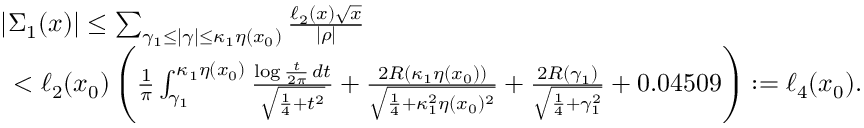<formula> <loc_0><loc_0><loc_500><loc_500>\begin{array} { r l } & { | \Sigma _ { 1 } ( x ) | \leq \sum _ { \gamma _ { 1 } \leq | \gamma | \leq \kappa _ { 1 } \eta ( x _ { 0 } ) } \frac { \ell _ { 2 } ( x ) \sqrt { x } } { | \rho | } } \\ & { \, < \ell _ { 2 } ( x _ { 0 } ) \left ( \frac { 1 } { \pi } \int _ { \gamma _ { 1 } } ^ { \kappa _ { 1 } \eta ( x _ { 0 } ) } \frac { \log { \frac { t } { 2 \pi } } \, d t } { \sqrt { \frac { 1 } { 4 } + t ^ { 2 } } } + \frac { 2 R ( \kappa _ { 1 } \eta ( x _ { 0 } ) ) } { \sqrt { \frac { 1 } { 4 } + \kappa _ { 1 } ^ { 2 } \eta ( x _ { 0 } ) ^ { 2 } } } + \frac { 2 R ( \gamma _ { 1 } ) } { \sqrt { \frac { 1 } { 4 } + \gamma _ { 1 } ^ { 2 } } } + 0 . 0 4 5 0 9 \right ) \colon = \ell _ { 4 } ( x _ { 0 } ) . } \end{array}</formula> 